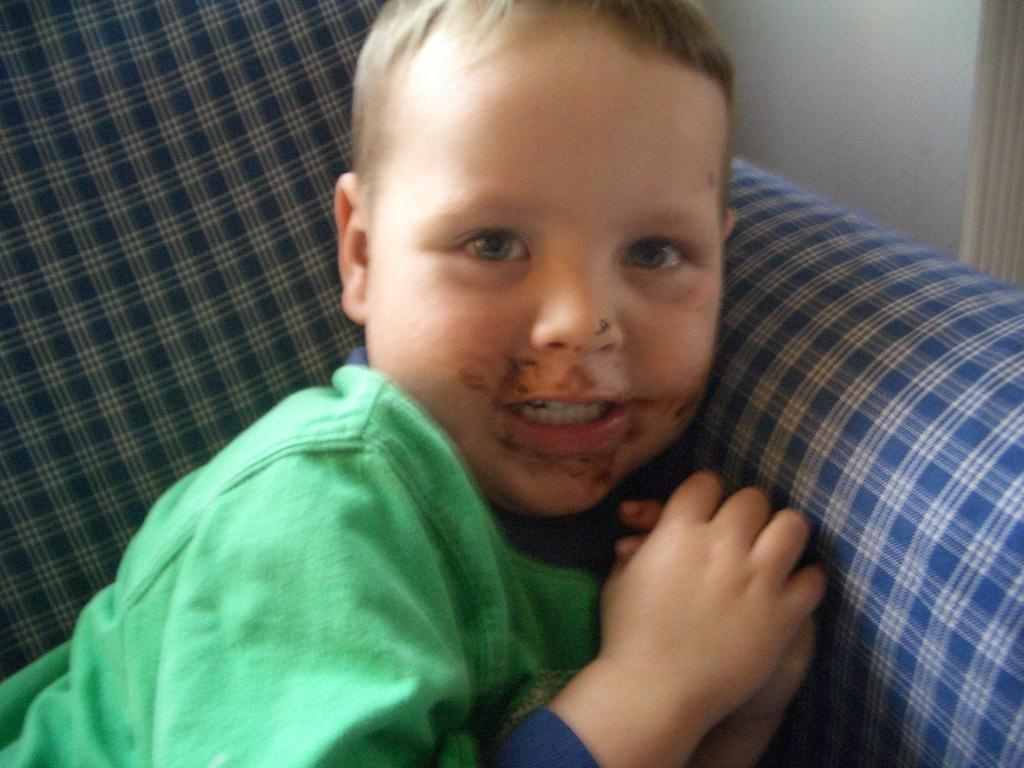What is the main subject of the image? There is a boy in the image. What is the boy wearing? The boy is wearing green clothes. Can you describe the background of the image? There is a blue color object in the background of the image. What is the boy's opinion on the leaf in the image? There is no leaf present in the image, so it is not possible to determine the boy's opinion on a leaf. 